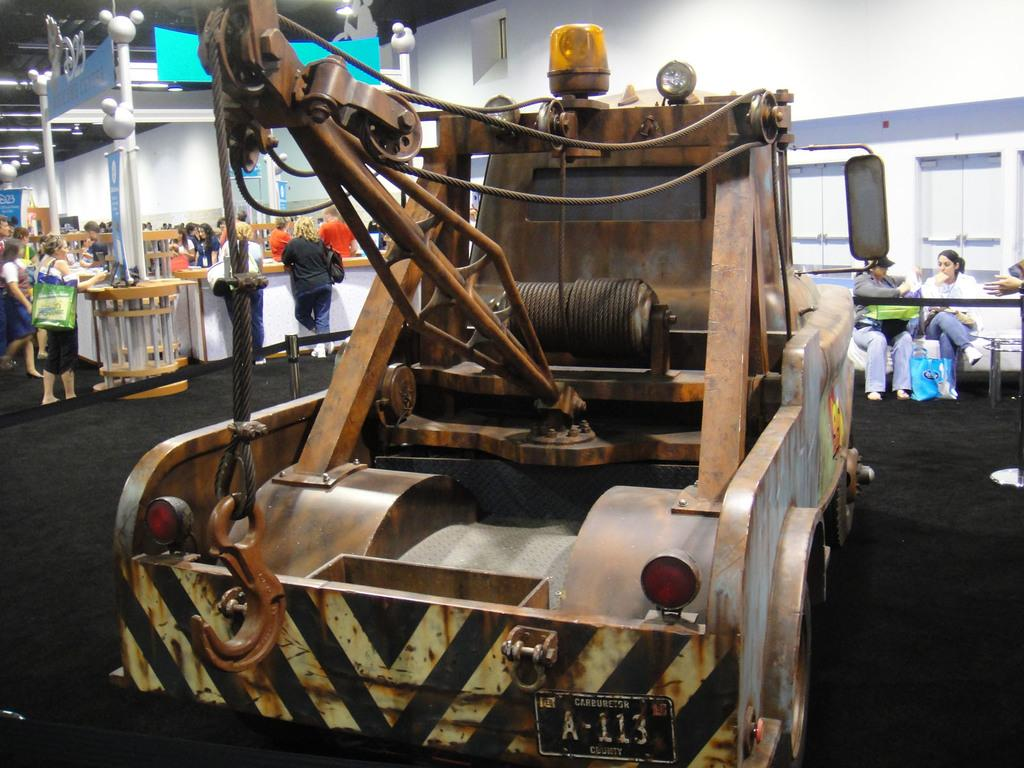What is the main subject in the middle of the image? There is a crane in the middle of the image. Who is the person on the right side of the image? A beautiful woman is sitting on a chair on the right side of the image. What is the woman wearing? The woman is wearing a white coat. What can be seen on the left side of the image? There are people standing on the left side of the image. What type of chin does the authority figure have in the image? There is no authority figure present in the image, and therefore no chin can be described. 